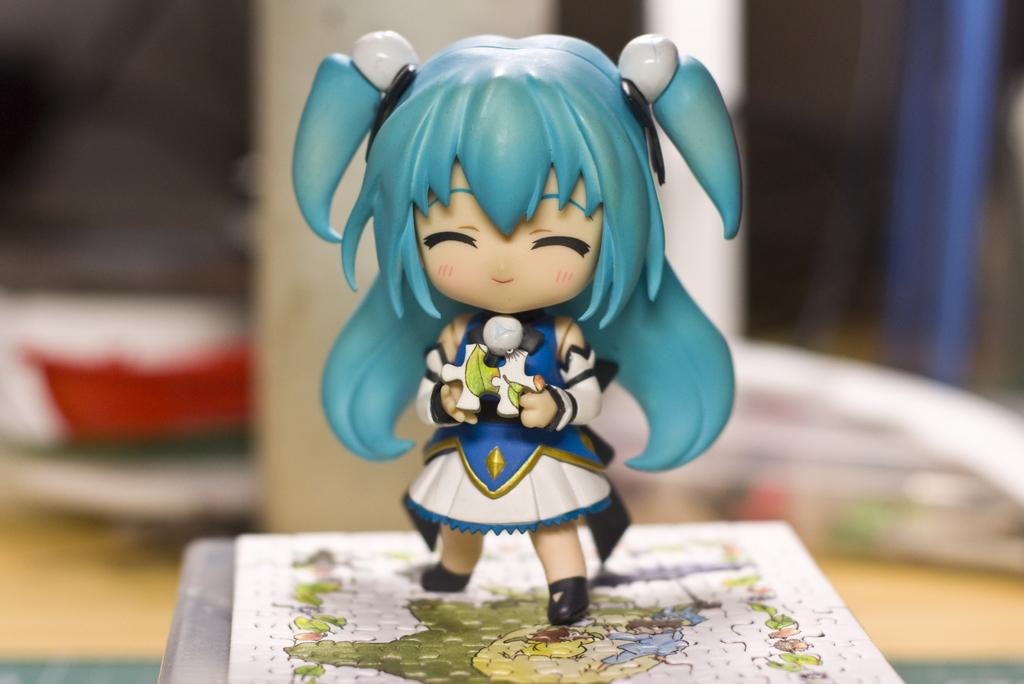Who is the main subject in the image? There is a girl in the image. What is the girl doing in the image? The girl is standing on a jigsaw puzzle. What is the toy holding in the image? The toy is holding a jigsaw puzzle piece. Can you describe the background in the image? The background behind the toy is blurry. What is the girl's voice like in the image? There is no information about the girl's voice in the image, as it is a still image and does not contain any audio. 